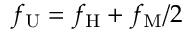Convert formula to latex. <formula><loc_0><loc_0><loc_500><loc_500>f _ { U } = f _ { H } + f _ { M } / 2</formula> 